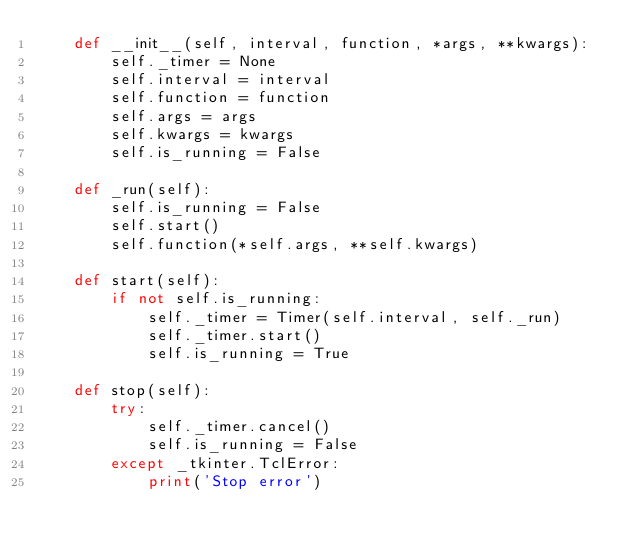<code> <loc_0><loc_0><loc_500><loc_500><_Python_>    def __init__(self, interval, function, *args, **kwargs):
        self._timer = None
        self.interval = interval
        self.function = function
        self.args = args
        self.kwargs = kwargs
        self.is_running = False

    def _run(self):
        self.is_running = False
        self.start()
        self.function(*self.args, **self.kwargs)

    def start(self):
        if not self.is_running:
            self._timer = Timer(self.interval, self._run)
            self._timer.start()
            self.is_running = True

    def stop(self):
        try:
            self._timer.cancel()
            self.is_running = False
        except _tkinter.TclError:
            print('Stop error')

</code> 